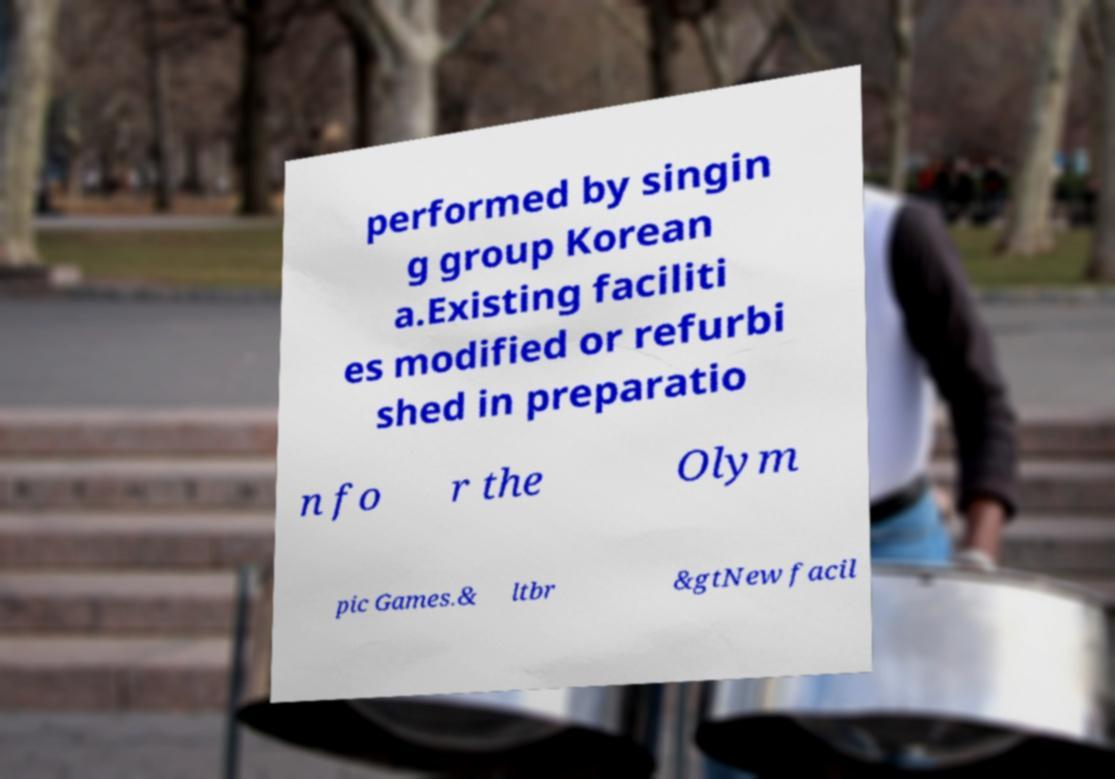Please read and relay the text visible in this image. What does it say? performed by singin g group Korean a.Existing faciliti es modified or refurbi shed in preparatio n fo r the Olym pic Games.& ltbr &gtNew facil 